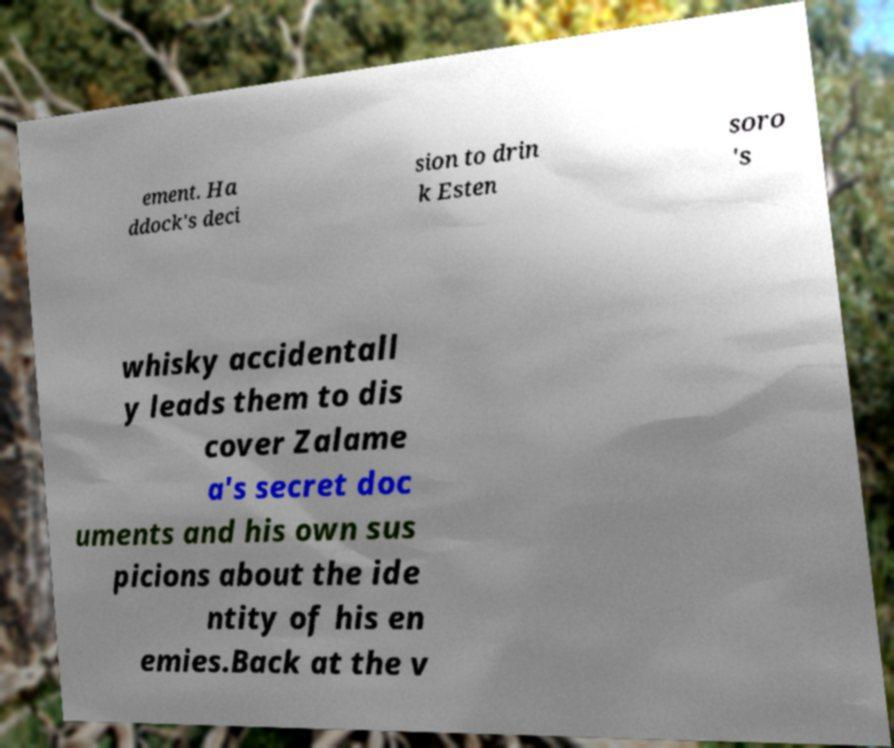What messages or text are displayed in this image? I need them in a readable, typed format. ement. Ha ddock's deci sion to drin k Esten soro 's whisky accidentall y leads them to dis cover Zalame a's secret doc uments and his own sus picions about the ide ntity of his en emies.Back at the v 